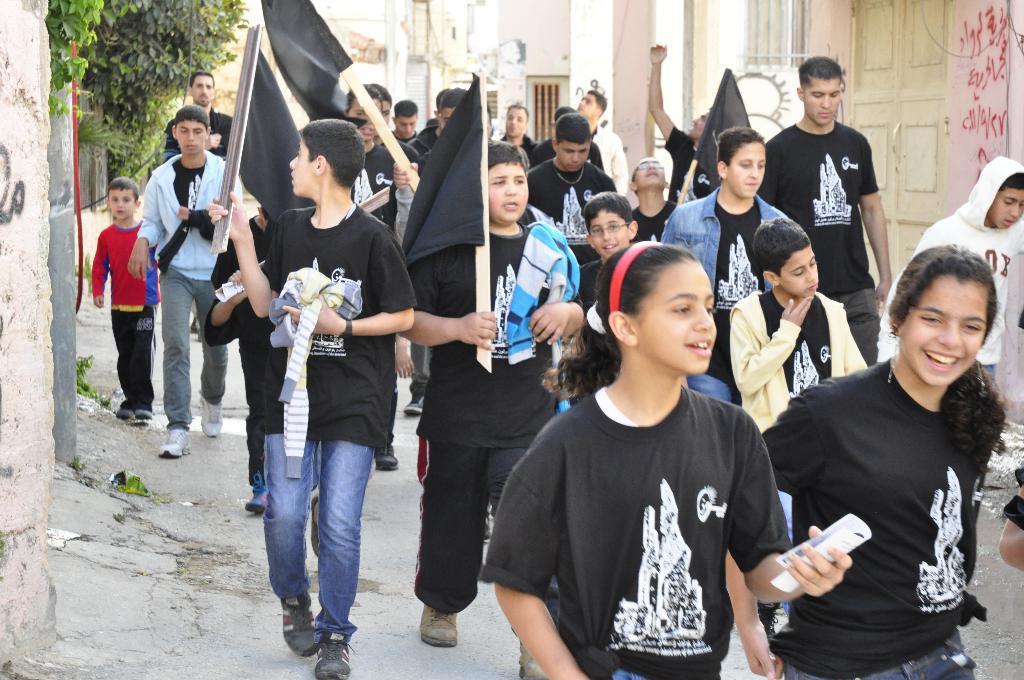Can you describe this image briefly? In this image, we can see a crowd. There are some kids wearing clothes and holding flags with their hands. There is a branch in the top left of the image. There is a door in the top right of the image. 